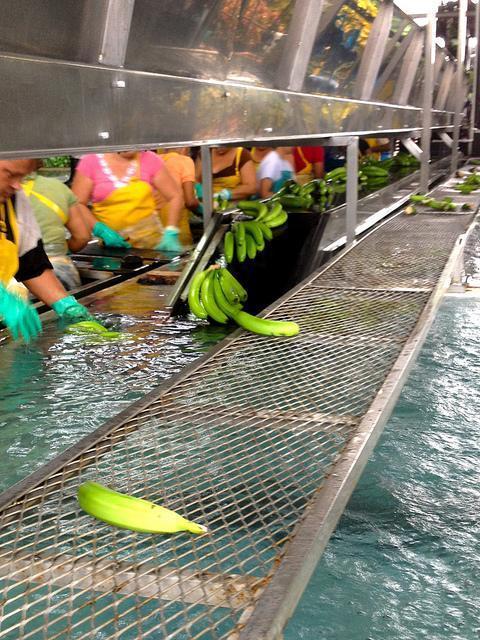How many bananas can you see?
Give a very brief answer. 2. How many people are in the photo?
Give a very brief answer. 4. How many sheep are there?
Give a very brief answer. 0. 